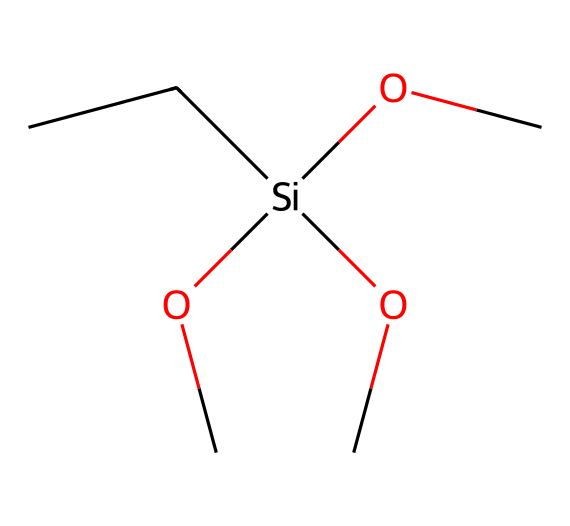What is the central atom in this silane coupling agent? The SMILES representation shows a silicon atom connected to various groups. The central atom is silicon, as indicated by the '[Si]' in the SMILES.
Answer: silicon How many carbon atoms are present in the molecule? Analyzing the SMILES, there are two "C" characters before the silicon, indicating two carbon atoms directly bonded to silicon. Therefore, there are a total of three carbon atoms, including the two connected to silicon and one in the propane-like structure.
Answer: three What functional groups are attached to the silicon atom? The SMILES shows the presence of 'OC' groups (alkoxy groups) connected to silicon. Specifically, there are three instances of 'OC' attached, which are functional groups typically indicating an alcohol.
Answer: alkoxy groups What type of chemical interactions are facilitated by this silane coupling agent? Given the structure, the silane will form covalent bonds with surfaces, such as glass or organic materials, and improve adhesion due to functional groups. This leads to enhanced composite performance.
Answer: improved adhesion How many total atoms are in the molecule? The SMILES shows two carbon atoms, one silicon atom, and three oxygen atoms from the alkoxy groups (3x O + 2x C + 1x Si); thus the total count is six atoms.
Answer: six What role does the silicon atom play in customized composite materials? Silicon in silane coupling agents enhances the bonding between the inorganic and organic phases in composites, improving durability and stability in varying environmental conditions.
Answer: bonding agent What is the total number of oxygen atoms in this silane? The structure indicates three 'OC' groups attached to silicon, which contributes three oxygen atoms to the molecule.
Answer: three 